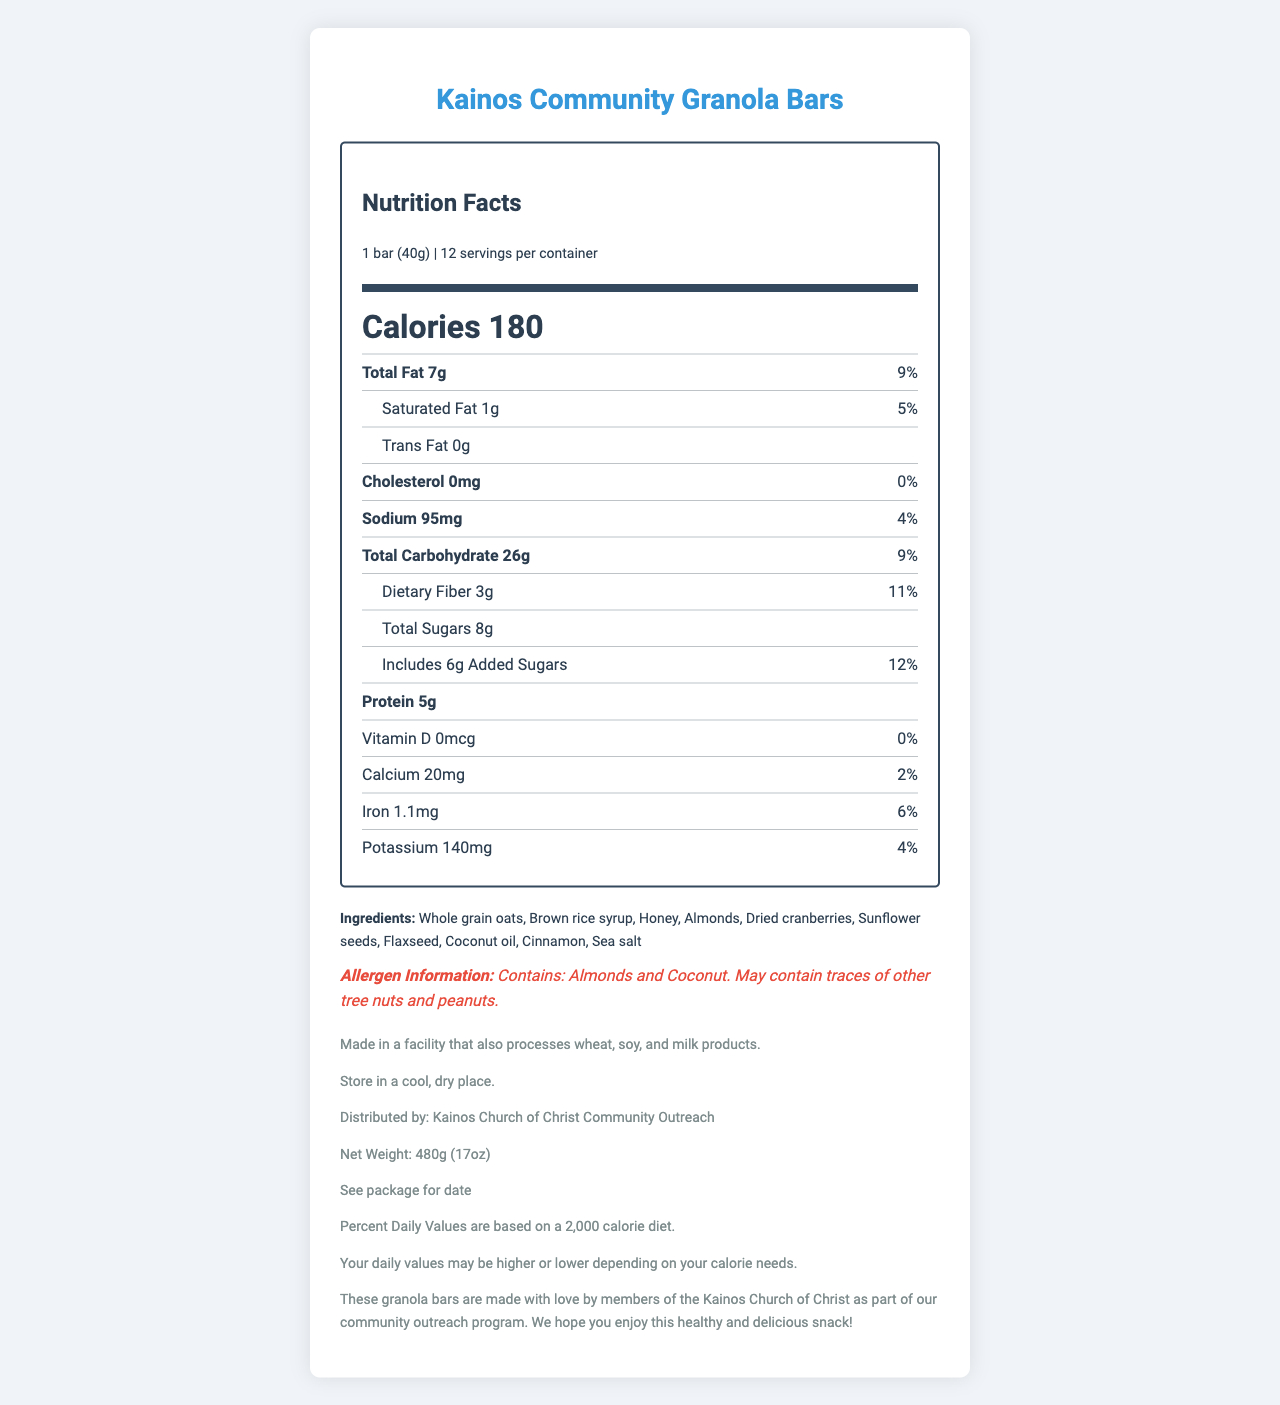what is the serving size? The serving size is clearly stated at the top of the nutrition label next to the product name and below the "Nutrition Facts" header.
Answer: 1 bar (40g) how much total fat is in one serving? The total fat for one serving is listed in the nutrition facts section as "Total Fat 7g."
Answer: 7g what percentage of daily value does the dietary fiber contribute? The percentage daily value for dietary fiber is shown next to its amount as "11%."
Answer: 11% how many grams of protein are in each granola bar? The amount of protein per serving is listed as "Protein 5g" in the nutrition facts section.
Answer: 5g what are the ingredients in these granola bars? The ingredients are listed in a section directly under "Ingredients."
Answer: Whole grain oats, Brown rice syrup, Honey, Almonds, Dried cranberries, Sunflower seeds, Flaxseed, Coconut oil, Cinnamon, Sea salt what is the amount of sodium per serving? A. 95mg B. 0mg C. 140mg D. 20mg The sodium content per serving is listed as "Sodium 95mg."
Answer: A how many servings are in one container of granola bars? A. 6 B. 12 C. 24 D. 8 The number of servings per container is listed as "12" next to the serving size information.
Answer: B does this product contain any allergens? The allergen information section indicates that the product contains almonds and coconut, and may contain traces of other tree nuts and peanuts.
Answer: Yes is there any cholesterol in these granola bars? The cholesterol content is listed as "0mg" with a 0% daily value, indicating no cholesterol.
Answer: No summarize the main idea of the document. The document is focused on providing detailed nutritional information, ingredients, and allergy warnings for the granola bars made by the Kainos Church of Christ for their community outreach program.
Answer: The document presents the nutrition facts, ingredients, allergen information, and additional information for Kainos Community Granola Bars. Each bar weighs 40g, provides 180 calories, has 7g of total fat, and includes whole grain oats and other nutritious ingredients. what is the best before date of the product? The document only states "See package for date," so the exact best before date is not provided in the document.
Answer: Cannot be determined 